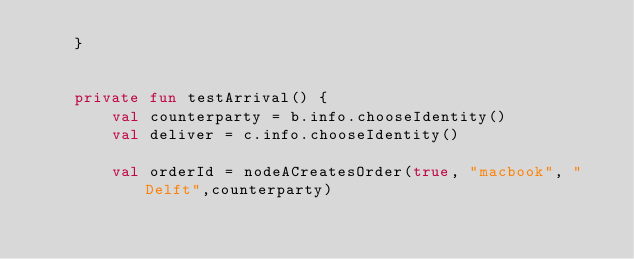<code> <loc_0><loc_0><loc_500><loc_500><_Kotlin_>    }


    private fun testArrival() {
        val counterparty = b.info.chooseIdentity()
        val deliver = c.info.chooseIdentity()

        val orderId = nodeACreatesOrder(true, "macbook", "Delft",counterparty)</code> 